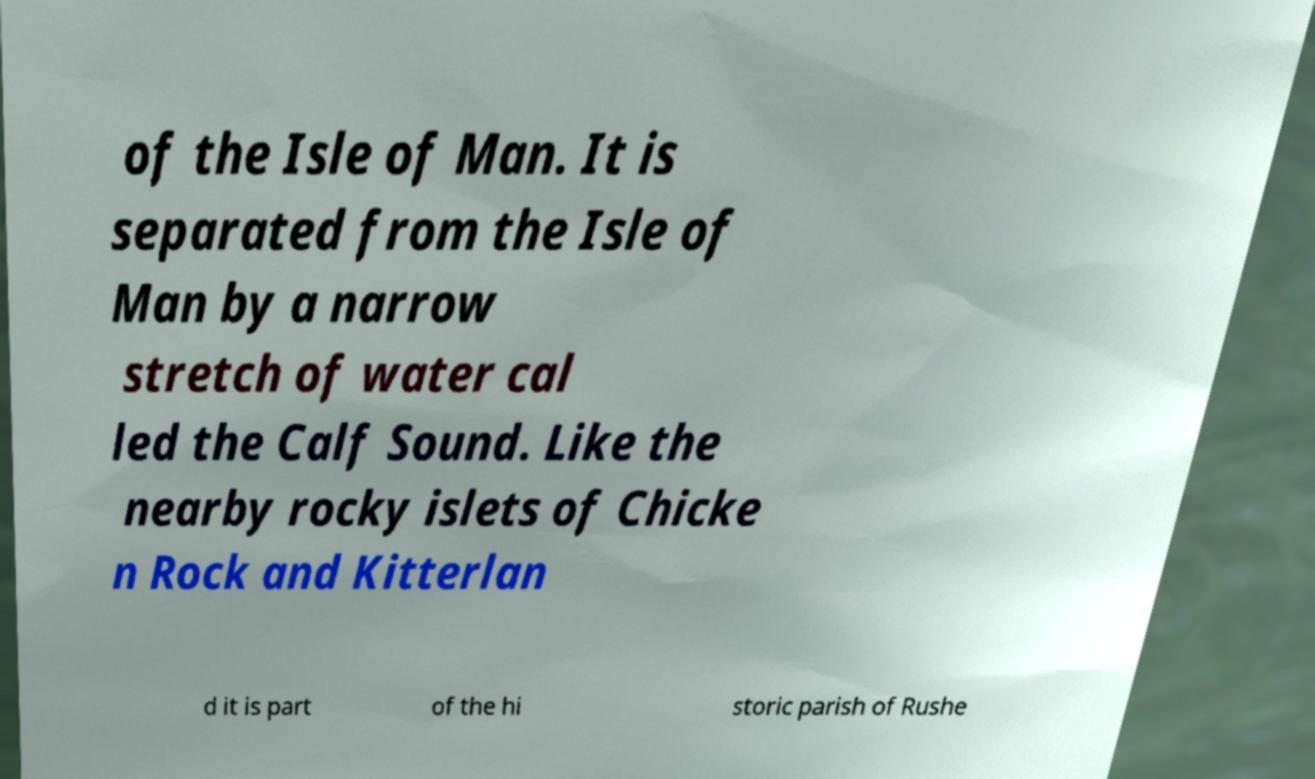What messages or text are displayed in this image? I need them in a readable, typed format. of the Isle of Man. It is separated from the Isle of Man by a narrow stretch of water cal led the Calf Sound. Like the nearby rocky islets of Chicke n Rock and Kitterlan d it is part of the hi storic parish of Rushe 